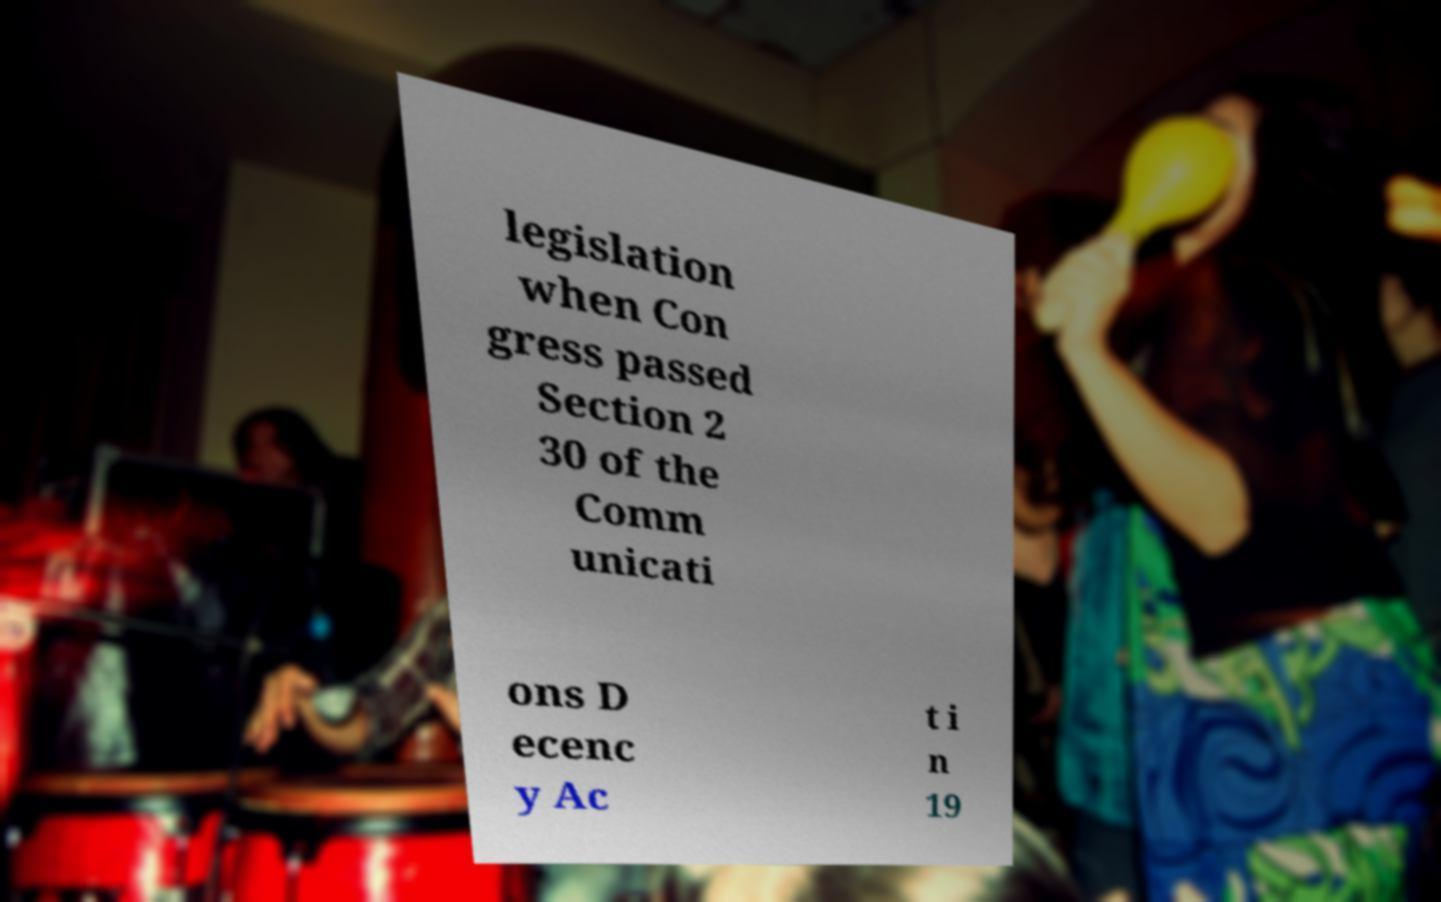What messages or text are displayed in this image? I need them in a readable, typed format. legislation when Con gress passed Section 2 30 of the Comm unicati ons D ecenc y Ac t i n 19 